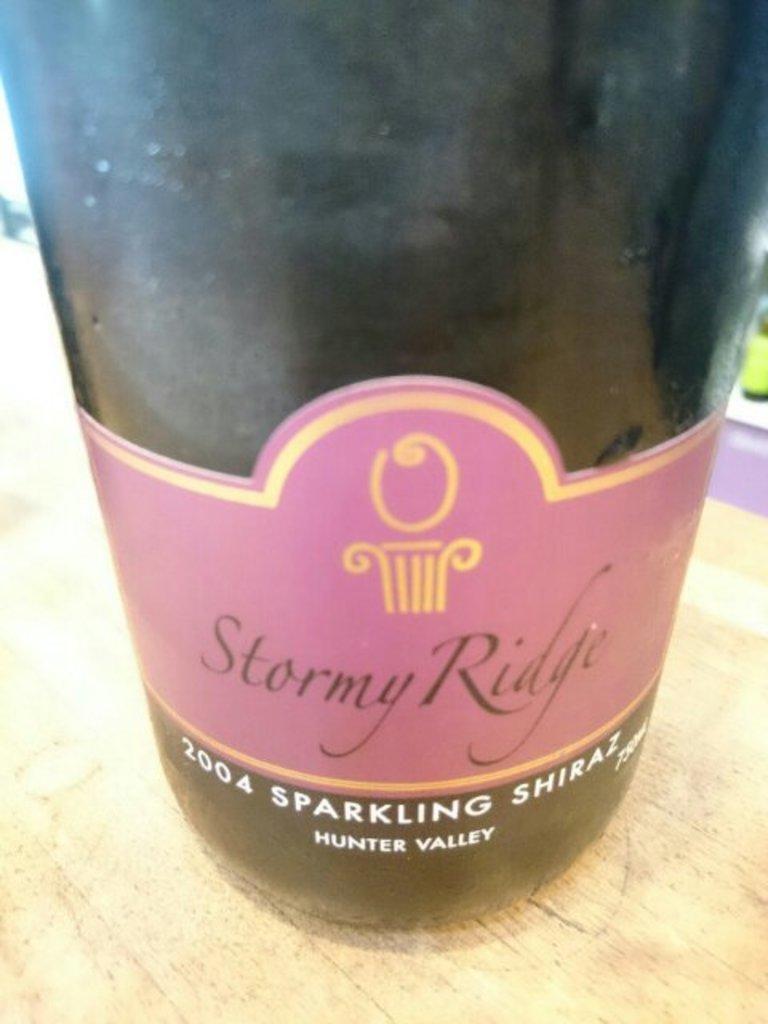Whats the year on the can?
Offer a terse response. 2004. 